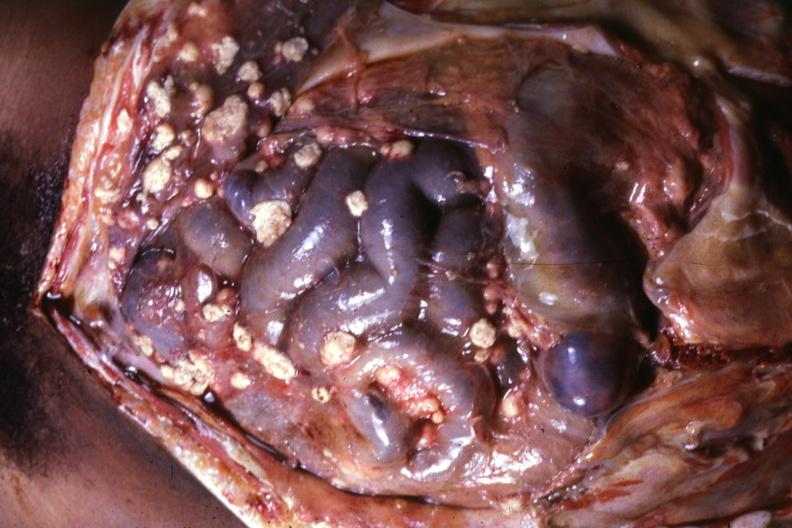what is present?
Answer the question using a single word or phrase. Tuberculous peritonitis 